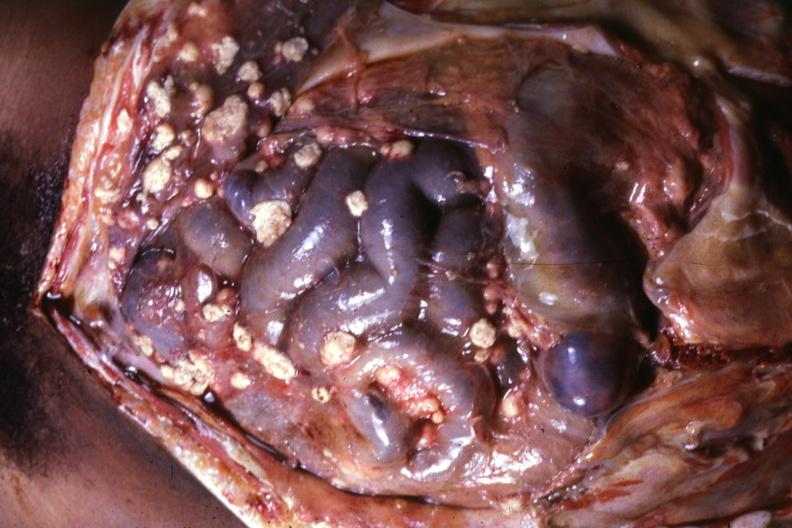what is present?
Answer the question using a single word or phrase. Tuberculous peritonitis 